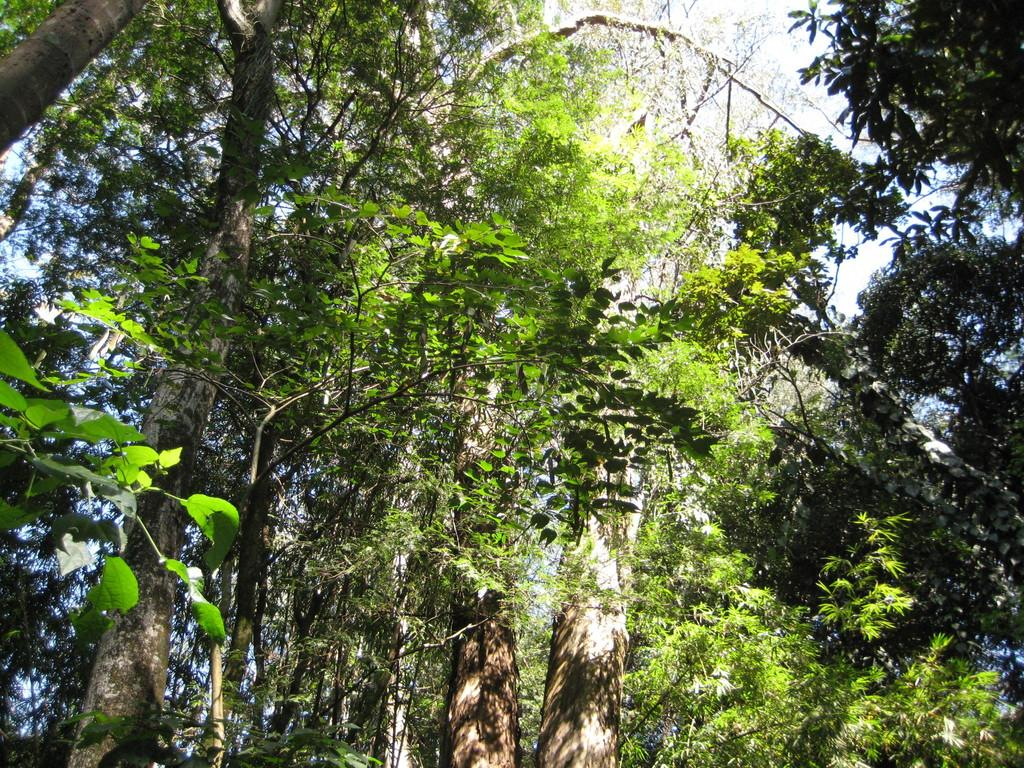What type of vegetation can be seen in the image? There are plants and trees in the image. Can you describe the plants and trees in the image? The image shows plants and trees, but specific details about their appearance cannot be determined from the provided facts. What disease is the uncle suffering from in the image? There is no uncle or any reference to a disease in the image; it only features plants and trees. 